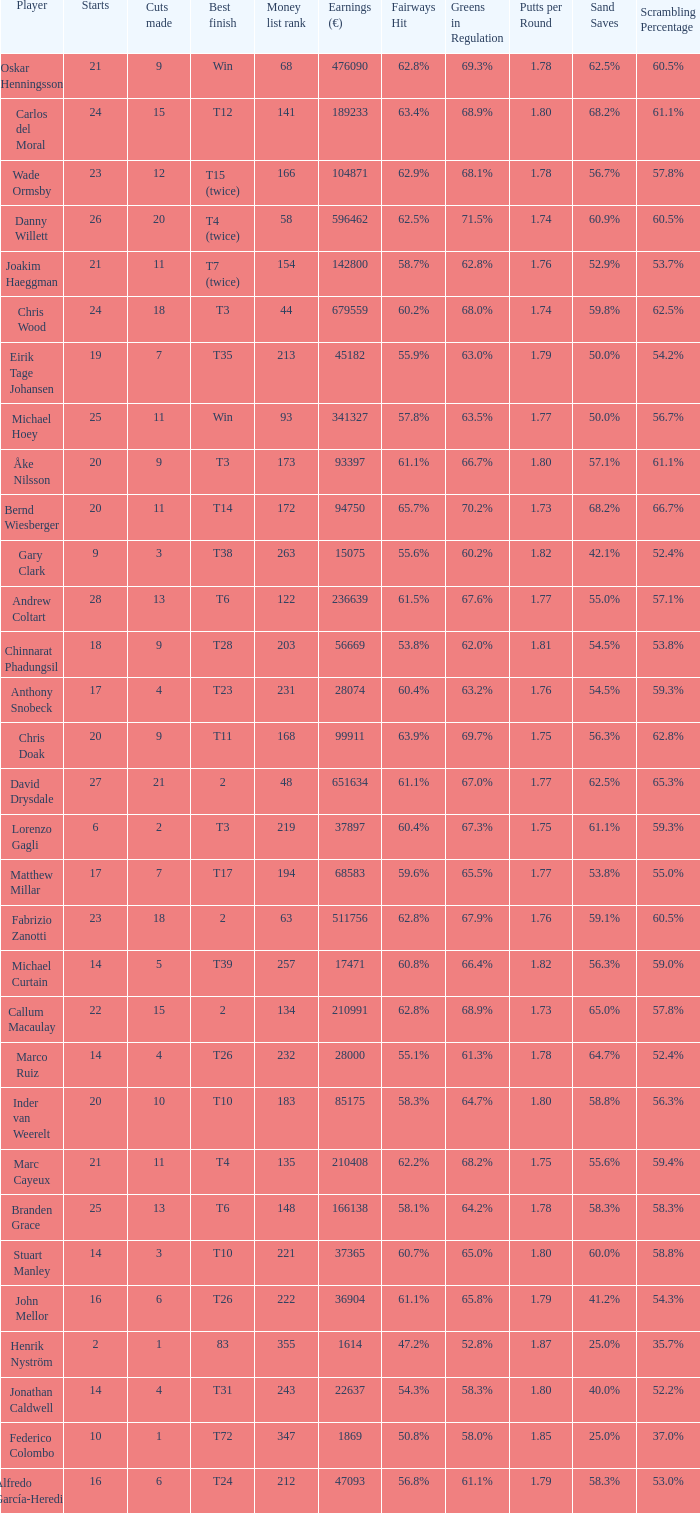How many cuts did Bernd Wiesberger make? 11.0. Would you mind parsing the complete table? {'header': ['Player', 'Starts', 'Cuts made', 'Best finish', 'Money list rank', 'Earnings (€)', 'Fairways Hit', 'Greens in Regulation', 'Putts per Round', 'Sand Saves', 'Scrambling Percentage'], 'rows': [['Oskar Henningsson', '21', '9', 'Win', '68', '476090', '62.8%', '69.3%', '1.78', '62.5%', '60.5%'], ['Carlos del Moral', '24', '15', 'T12', '141', '189233', '63.4%', '68.9%', '1.80', '68.2%', '61.1%'], ['Wade Ormsby', '23', '12', 'T15 (twice)', '166', '104871', '62.9%', '68.1%', '1.78', '56.7%', '57.8%'], ['Danny Willett', '26', '20', 'T4 (twice)', '58', '596462', '62.5%', '71.5%', '1.74', '60.9%', '60.5%'], ['Joakim Haeggman', '21', '11', 'T7 (twice)', '154', '142800', '58.7%', '62.8%', '1.76', '52.9%', '53.7%'], ['Chris Wood', '24', '18', 'T3', '44', '679559', '60.2%', '68.0%', '1.74', '59.8%', '62.5%'], ['Eirik Tage Johansen', '19', '7', 'T35', '213', '45182', '55.9%', '63.0%', '1.79', '50.0%', '54.2%'], ['Michael Hoey', '25', '11', 'Win', '93', '341327', '57.8%', '63.5%', '1.77', '50.0%', '56.7%'], ['Åke Nilsson', '20', '9', 'T3', '173', '93397', '61.1%', '66.7%', '1.80', '57.1%', '61.1%'], ['Bernd Wiesberger', '20', '11', 'T14', '172', '94750', '65.7%', '70.2%', '1.73', '68.2%', '66.7%'], ['Gary Clark', '9', '3', 'T38', '263', '15075', '55.6%', '60.2%', '1.82', '42.1%', '52.4%'], ['Andrew Coltart', '28', '13', 'T6', '122', '236639', '61.5%', '67.6%', '1.77', '55.0%', '57.1%'], ['Chinnarat Phadungsil', '18', '9', 'T28', '203', '56669', '53.8%', '62.0%', '1.81', '54.5%', '53.8%'], ['Anthony Snobeck', '17', '4', 'T23', '231', '28074', '60.4%', '63.2%', '1.76', '54.5%', '59.3%'], ['Chris Doak', '20', '9', 'T11', '168', '99911', '63.9%', '69.7%', '1.75', '56.3%', '62.8%'], ['David Drysdale', '27', '21', '2', '48', '651634', '61.1%', '67.0%', '1.77', '62.5%', '65.3%'], ['Lorenzo Gagli', '6', '2', 'T3', '219', '37897', '60.4%', '67.3%', '1.75', '61.1%', '59.3%'], ['Matthew Millar', '17', '7', 'T17', '194', '68583', '59.6%', '65.5%', '1.77', '53.8%', '55.0%'], ['Fabrizio Zanotti', '23', '18', '2', '63', '511756', '62.8%', '67.9%', '1.76', '59.1%', '60.5%'], ['Michael Curtain', '14', '5', 'T39', '257', '17471', '60.8%', '66.4%', '1.82', '56.3%', '59.0%'], ['Callum Macaulay', '22', '15', '2', '134', '210991', '62.8%', '68.9%', '1.73', '65.0%', '57.8%'], ['Marco Ruiz', '14', '4', 'T26', '232', '28000', '55.1%', '61.3%', '1.78', '64.7%', '52.4%'], ['Inder van Weerelt', '20', '10', 'T10', '183', '85175', '58.3%', '64.7%', '1.80', '58.8%', '56.3%'], ['Marc Cayeux', '21', '11', 'T4', '135', '210408', '62.2%', '68.2%', '1.75', '55.6%', '59.4%'], ['Branden Grace', '25', '13', 'T6', '148', '166138', '58.1%', '64.2%', '1.78', '58.3%', '58.3%'], ['Stuart Manley', '14', '3', 'T10', '221', '37365', '60.7%', '65.0%', '1.80', '60.0%', '58.8%'], ['John Mellor', '16', '6', 'T26', '222', '36904', '61.1%', '65.8%', '1.79', '41.2%', '54.3%'], ['Henrik Nyström', '2', '1', '83', '355', '1614', '47.2%', '52.8%', '1.87', '25.0%', '35.7%'], ['Jonathan Caldwell', '14', '4', 'T31', '243', '22637', '54.3%', '58.3%', '1.80', '40.0%', '52.2%'], ['Federico Colombo', '10', '1', 'T72', '347', '1869', '50.8%', '58.0%', '1.85', '25.0%', '37.0%'], ['Alfredo García-Heredia', '16', '6', 'T24', '212', '47093', '56.8%', '61.1%', '1.79', '58.3%', '53.0%']]} 